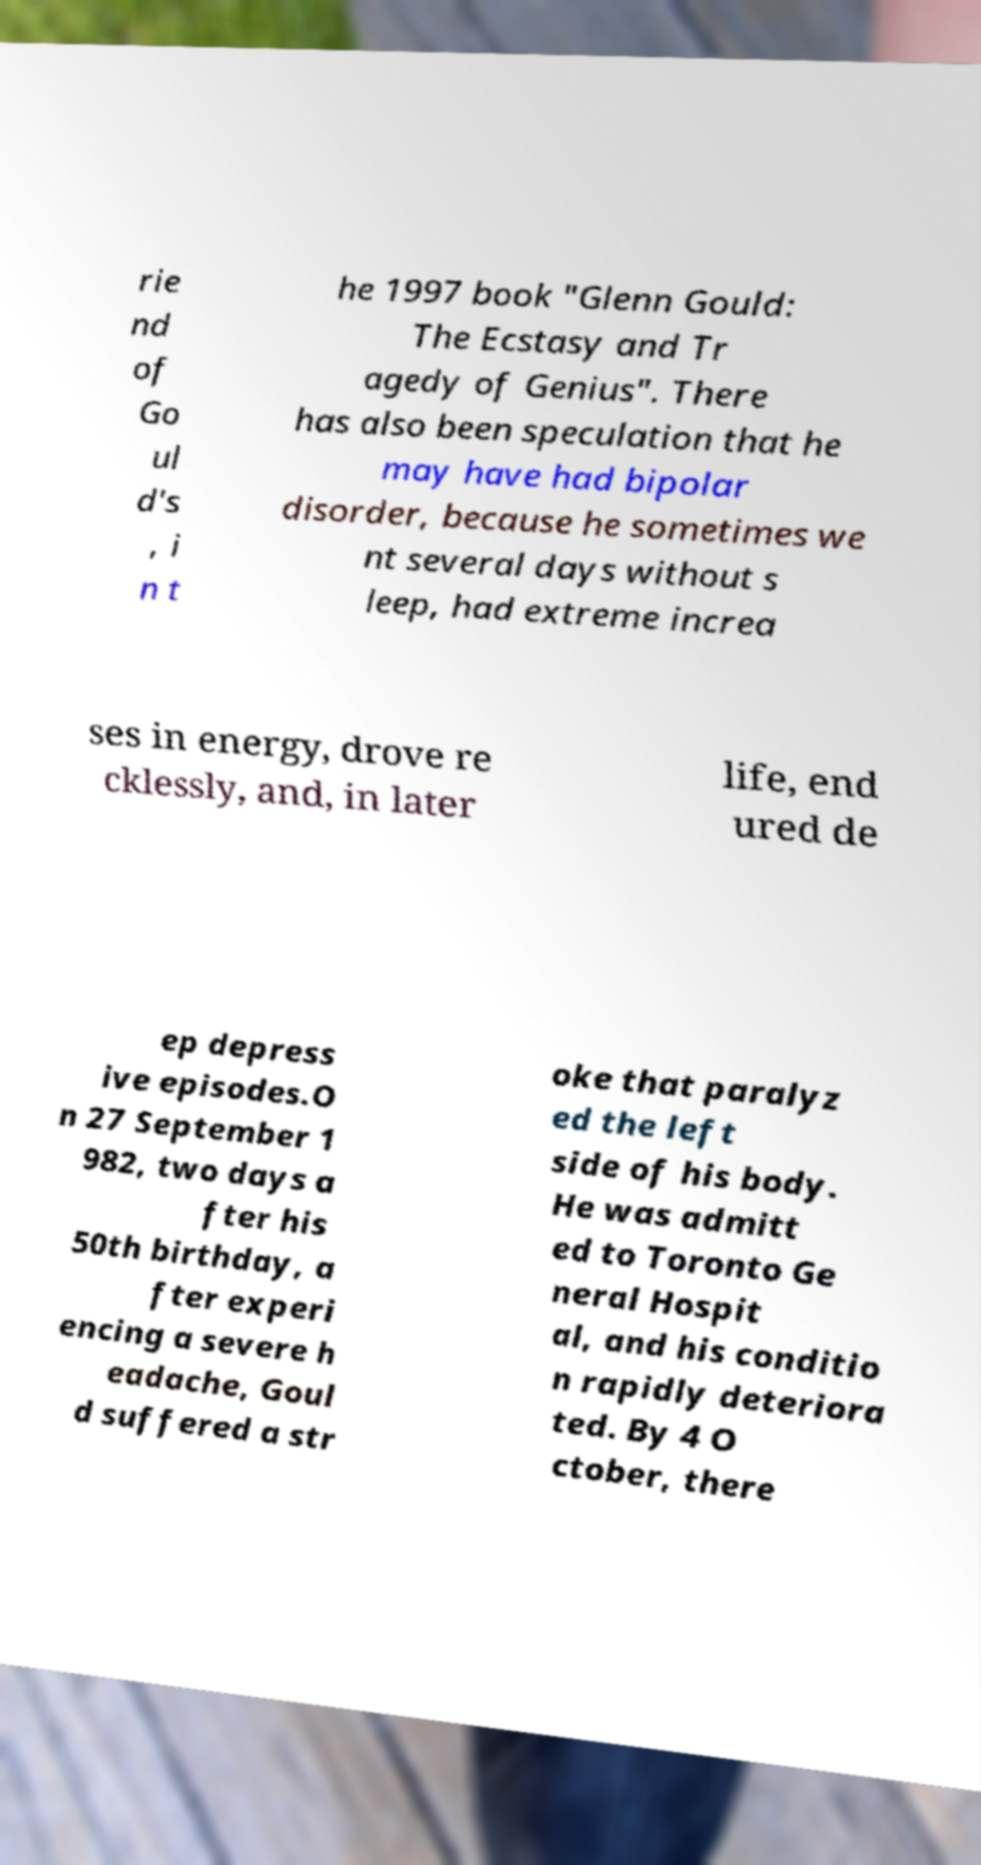Please identify and transcribe the text found in this image. rie nd of Go ul d's , i n t he 1997 book "Glenn Gould: The Ecstasy and Tr agedy of Genius". There has also been speculation that he may have had bipolar disorder, because he sometimes we nt several days without s leep, had extreme increa ses in energy, drove re cklessly, and, in later life, end ured de ep depress ive episodes.O n 27 September 1 982, two days a fter his 50th birthday, a fter experi encing a severe h eadache, Goul d suffered a str oke that paralyz ed the left side of his body. He was admitt ed to Toronto Ge neral Hospit al, and his conditio n rapidly deteriora ted. By 4 O ctober, there 